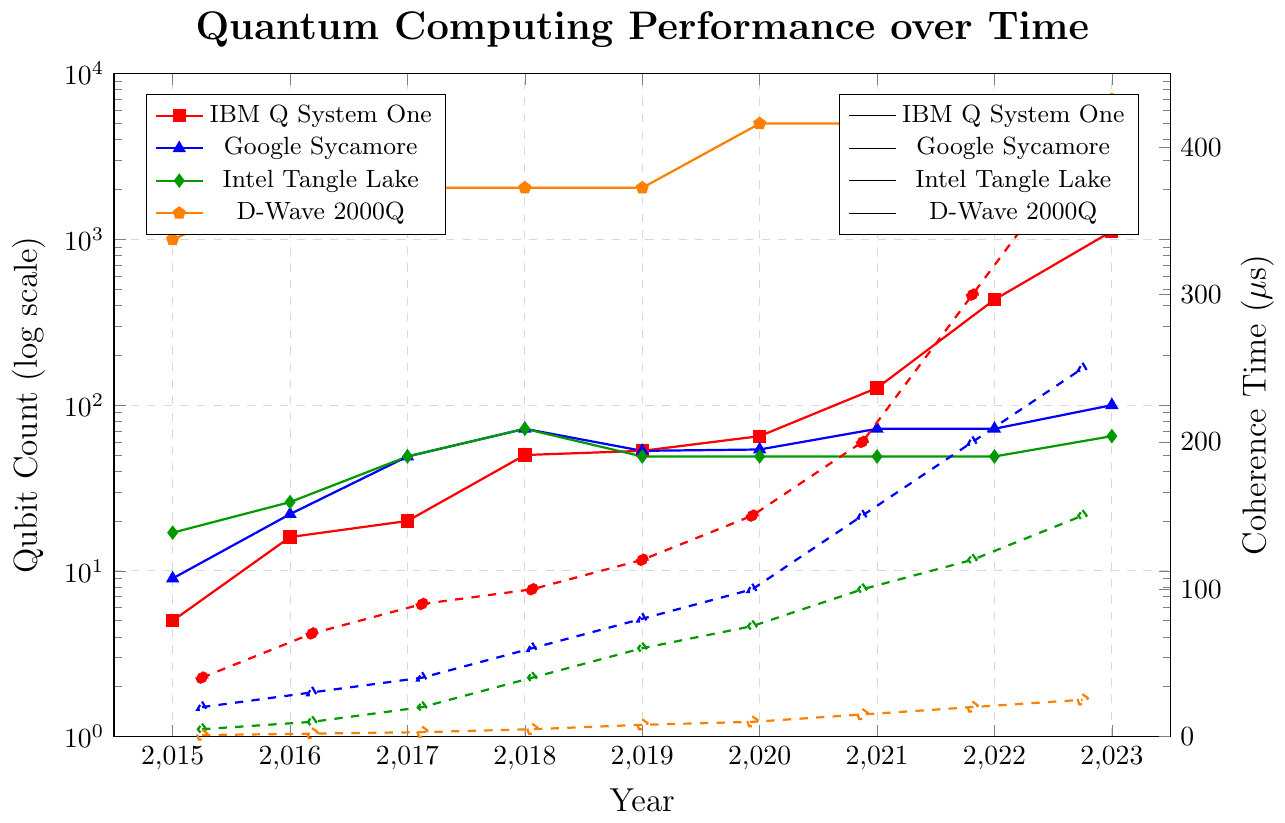How many qubits did IBM Q System One have in 2021 compared to Google Sycamore? IBM Q System One had 127 qubits in 2021, while Google Sycamore had 72 qubits in the same year.
Answer: IBM Q System One had 55 more qubits than Google Sycamore What was the rate of increase in coherence time for D-Wave 2000Q between 2015 and 2023? In 2015, D-Wave 2000Q's coherence time was 1 μs and in 2023 it was 25 μs. Therefore, the increase was 25 - 1 = 24 μs over 8 years, which averages to an increase of 24/8 = 3 μs per year.
Answer: 3 μs per year Which system had the highest coherence time in 2023 and by how much? IBM Q System One had the highest coherence time in 2023, at 400 μs. The next highest was Google Sycamore with coherence time of 250 μs. The difference is 400 - 250 = 150 μs.
Answer: IBM Q System One, 150 μs What is the total number of qubits for Intel Tangle Lake over the years 2015 to 2017? The numbers are 2015: 17 qubits, 2016: 26 qubits, and 2017: 49 qubits. Summing them up gives 17 + 26 + 49 = 92 qubits.
Answer: 92 qubits Compare the coherence time improvement from 2015 to 2018 for IBM Q System One and Intel Tangle Lake. Which one improved more and by how much? For IBM Q System One, coherence time improved from 40 μs in 2015 to 100 μs in 2018, an increase of 60 μs. For Intel Tangle Lake, it improved from 5 μs to 40 μs, an increase of 35 μs. Therefore, IBM Q System One improved more by 60 - 35 = 25 μs.
Answer: IBM Q System One, 25 μs How did the number of qubits for D-Wave 2000Q change between 2018 and 2020? The number of qubits for D-Wave 2000Q remained the same from 2018 (2048 qubits) to 2019 (2048 qubits) and then increased to 5000 qubits in 2020.
Answer: It increased by 2952 qubits in 2020 What is the average coherence time for Google Sycamore over the period 2015 to 2023? The coherence times for the years 2015 to 2023 are: 20, 30, 40, 60, 80, 100, 150, 200, 250 μs. The sum of these values is 930 μs. There are 9 years, so the average coherence time is 930/9 ≈ 103.33 μs.
Answer: 103.33 μs 